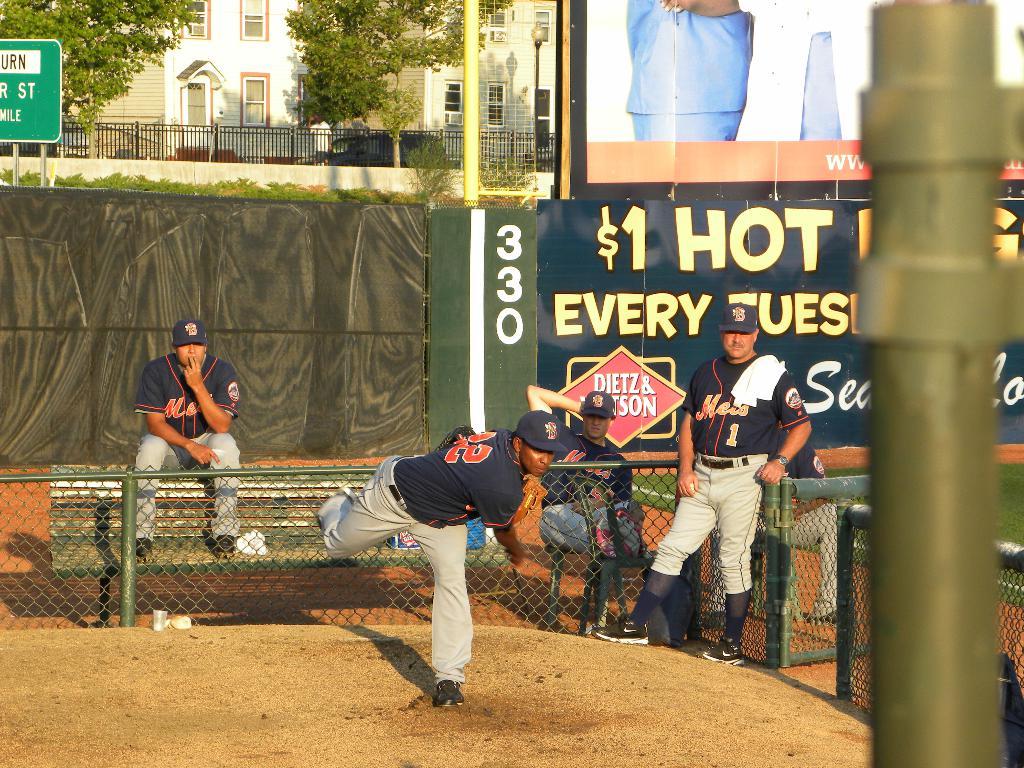Whats are the 3 digit numbers posted on the green board behind the players?
Your answer should be compact. 330. 